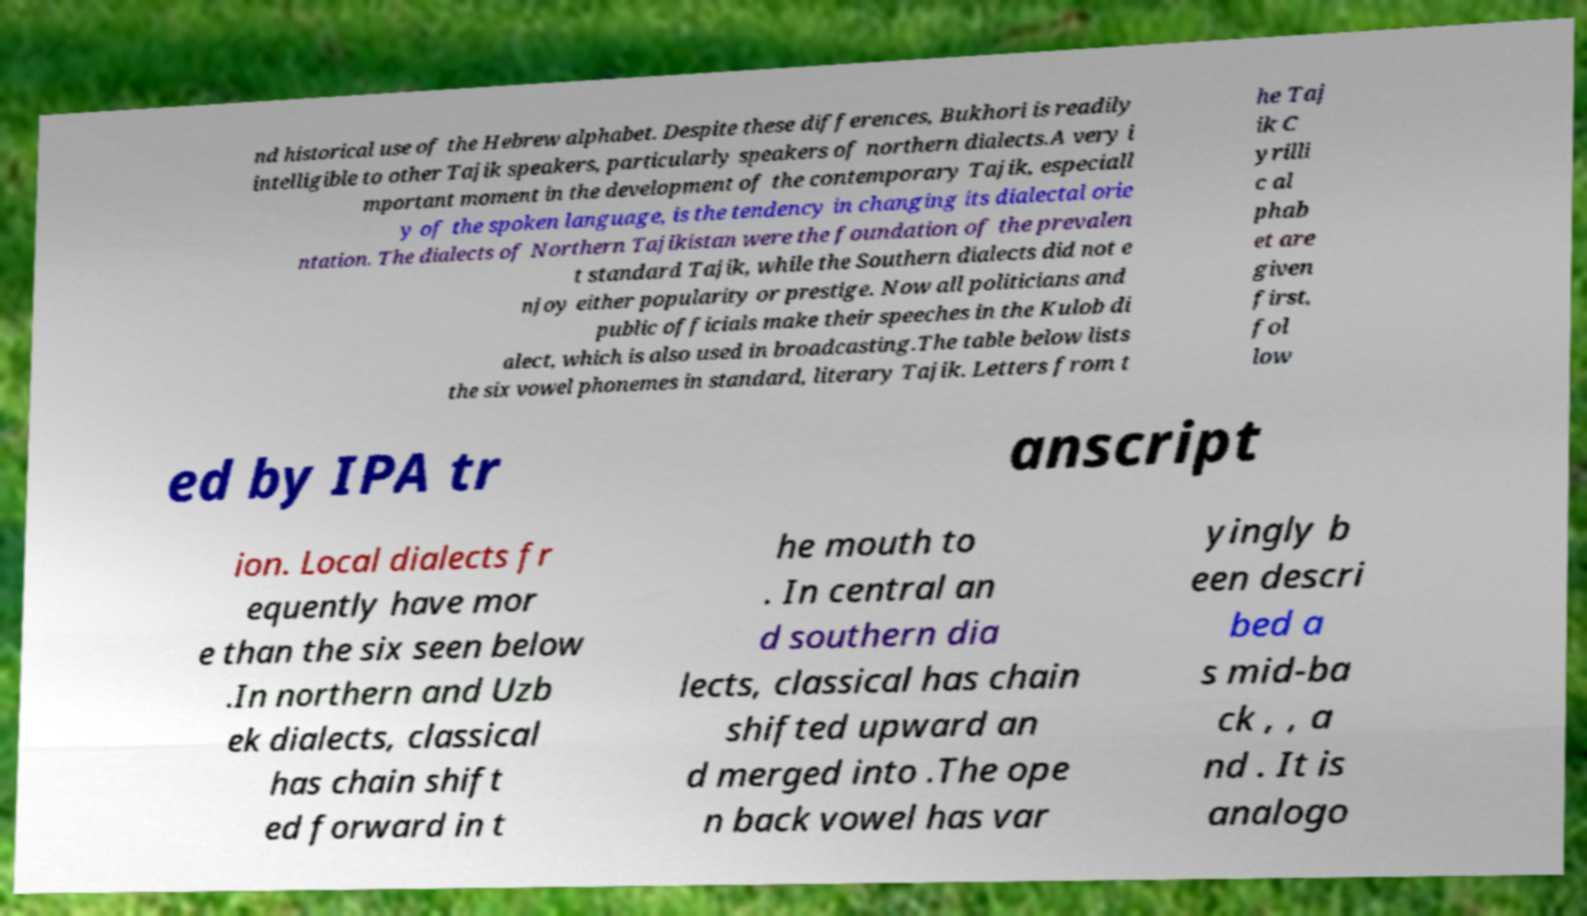Could you extract and type out the text from this image? nd historical use of the Hebrew alphabet. Despite these differences, Bukhori is readily intelligible to other Tajik speakers, particularly speakers of northern dialects.A very i mportant moment in the development of the contemporary Tajik, especiall y of the spoken language, is the tendency in changing its dialectal orie ntation. The dialects of Northern Tajikistan were the foundation of the prevalen t standard Tajik, while the Southern dialects did not e njoy either popularity or prestige. Now all politicians and public officials make their speeches in the Kulob di alect, which is also used in broadcasting.The table below lists the six vowel phonemes in standard, literary Tajik. Letters from t he Taj ik C yrilli c al phab et are given first, fol low ed by IPA tr anscript ion. Local dialects fr equently have mor e than the six seen below .In northern and Uzb ek dialects, classical has chain shift ed forward in t he mouth to . In central an d southern dia lects, classical has chain shifted upward an d merged into .The ope n back vowel has var yingly b een descri bed a s mid-ba ck , , a nd . It is analogo 